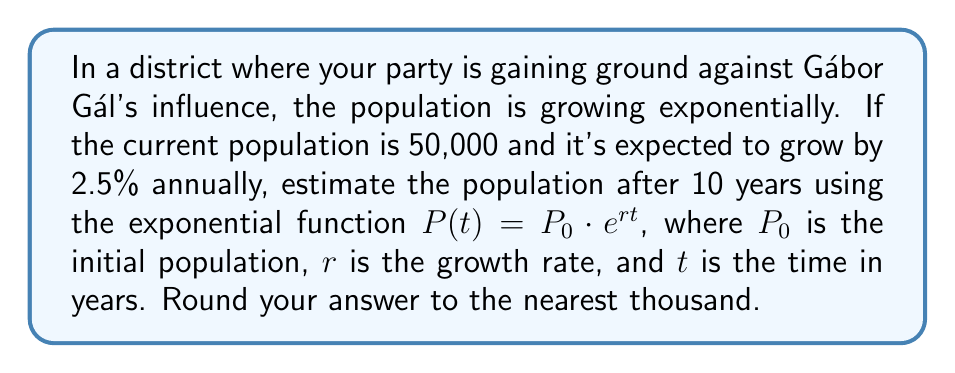What is the answer to this math problem? To solve this problem, we'll use the exponential function $P(t) = P_0 \cdot e^{rt}$ with the given information:

1. Initial population $P_0 = 50,000$
2. Annual growth rate $r = 2.5\% = 0.025$
3. Time $t = 10$ years

Let's substitute these values into the equation:

$P(10) = 50,000 \cdot e^{0.025 \cdot 10}$

Now, let's calculate step by step:

1. Simplify the exponent: $0.025 \cdot 10 = 0.25$
2. Calculate $e^{0.25}$:
   $e^{0.25} \approx 1.2840$
3. Multiply: $50,000 \cdot 1.2840 = 64,200$

Rounding to the nearest thousand: 64,000

Therefore, the estimated population after 10 years is approximately 64,000.
Answer: 64,000 